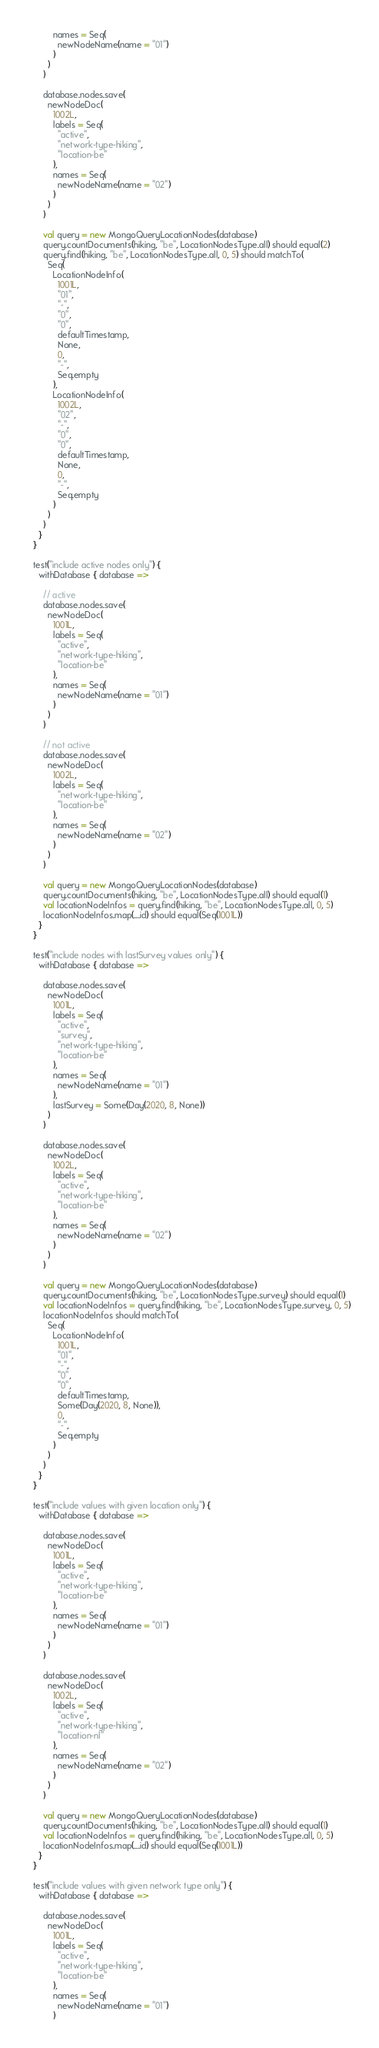<code> <loc_0><loc_0><loc_500><loc_500><_Scala_>          names = Seq(
            newNodeName(name = "01")
          )
        )
      )

      database.nodes.save(
        newNodeDoc(
          1002L,
          labels = Seq(
            "active",
            "network-type-hiking",
            "location-be"
          ),
          names = Seq(
            newNodeName(name = "02")
          )
        )
      )

      val query = new MongoQueryLocationNodes(database)
      query.countDocuments(hiking, "be", LocationNodesType.all) should equal(2)
      query.find(hiking, "be", LocationNodesType.all, 0, 5) should matchTo(
        Seq(
          LocationNodeInfo(
            1001L,
            "01",
            "-",
            "0",
            "0",
            defaultTimestamp,
            None,
            0,
            "-",
            Seq.empty
          ),
          LocationNodeInfo(
            1002L,
            "02",
            "-",
            "0",
            "0",
            defaultTimestamp,
            None,
            0,
            "-",
            Seq.empty
          )
        )
      )
    }
  }

  test("include active nodes only") {
    withDatabase { database =>

      // active
      database.nodes.save(
        newNodeDoc(
          1001L,
          labels = Seq(
            "active",
            "network-type-hiking",
            "location-be"
          ),
          names = Seq(
            newNodeName(name = "01")
          )
        )
      )

      // not active
      database.nodes.save(
        newNodeDoc(
          1002L,
          labels = Seq(
            "network-type-hiking",
            "location-be"
          ),
          names = Seq(
            newNodeName(name = "02")
          )
        )
      )

      val query = new MongoQueryLocationNodes(database)
      query.countDocuments(hiking, "be", LocationNodesType.all) should equal(1)
      val locationNodeInfos = query.find(hiking, "be", LocationNodesType.all, 0, 5)
      locationNodeInfos.map(_.id) should equal(Seq(1001L))
    }
  }

  test("include nodes with lastSurvey values only") {
    withDatabase { database =>

      database.nodes.save(
        newNodeDoc(
          1001L,
          labels = Seq(
            "active",
            "survey",
            "network-type-hiking",
            "location-be"
          ),
          names = Seq(
            newNodeName(name = "01")
          ),
          lastSurvey = Some(Day(2020, 8, None))
        )
      )

      database.nodes.save(
        newNodeDoc(
          1002L,
          labels = Seq(
            "active",
            "network-type-hiking",
            "location-be"
          ),
          names = Seq(
            newNodeName(name = "02")
          )
        )
      )

      val query = new MongoQueryLocationNodes(database)
      query.countDocuments(hiking, "be", LocationNodesType.survey) should equal(1)
      val locationNodeInfos = query.find(hiking, "be", LocationNodesType.survey, 0, 5)
      locationNodeInfos should matchTo(
        Seq(
          LocationNodeInfo(
            1001L,
            "01",
            "-",
            "0",
            "0",
            defaultTimestamp,
            Some(Day(2020, 8, None)),
            0,
            "-",
            Seq.empty
          )
        )
      )
    }
  }

  test("include values with given location only") {
    withDatabase { database =>

      database.nodes.save(
        newNodeDoc(
          1001L,
          labels = Seq(
            "active",
            "network-type-hiking",
            "location-be"
          ),
          names = Seq(
            newNodeName(name = "01")
          )
        )
      )

      database.nodes.save(
        newNodeDoc(
          1002L,
          labels = Seq(
            "active",
            "network-type-hiking",
            "location-nl"
          ),
          names = Seq(
            newNodeName(name = "02")
          )
        )
      )

      val query = new MongoQueryLocationNodes(database)
      query.countDocuments(hiking, "be", LocationNodesType.all) should equal(1)
      val locationNodeInfos = query.find(hiking, "be", LocationNodesType.all, 0, 5)
      locationNodeInfos.map(_.id) should equal(Seq(1001L))
    }
  }

  test("include values with given network type only") {
    withDatabase { database =>

      database.nodes.save(
        newNodeDoc(
          1001L,
          labels = Seq(
            "active",
            "network-type-hiking",
            "location-be"
          ),
          names = Seq(
            newNodeName(name = "01")
          )</code> 